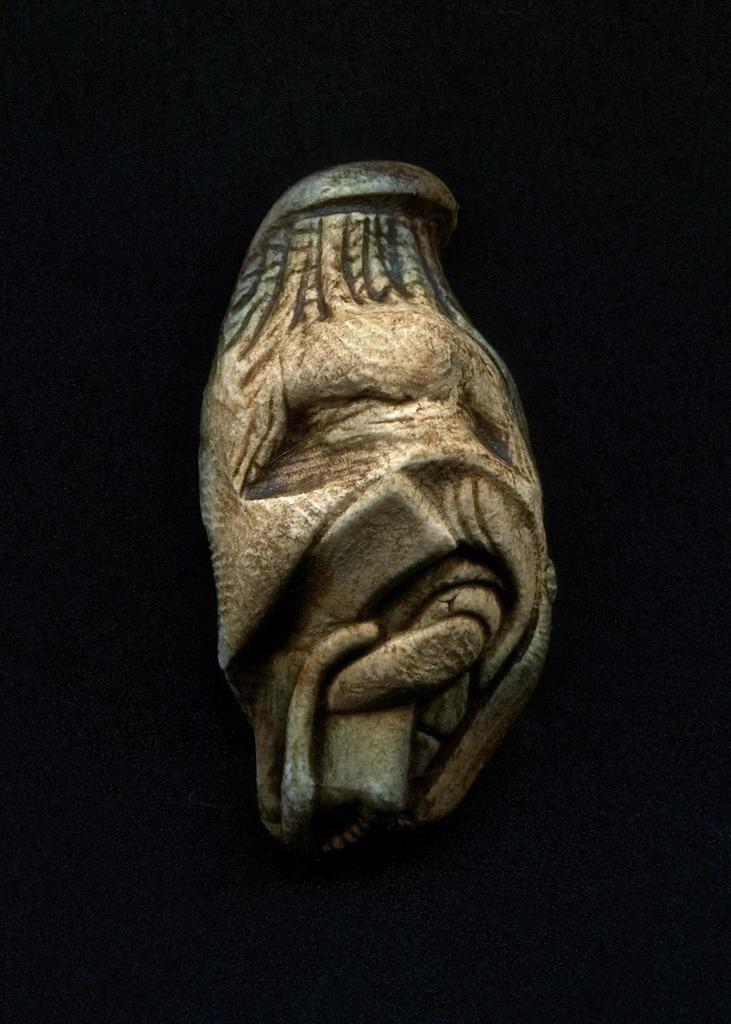Describe this image in one or two sentences. In this picture we can see a sculpture and in the background it is dark. 